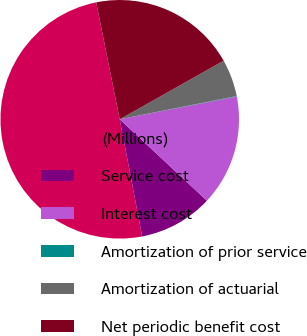Convert chart to OTSL. <chart><loc_0><loc_0><loc_500><loc_500><pie_chart><fcel>(Millions)<fcel>Service cost<fcel>Interest cost<fcel>Amortization of prior service<fcel>Amortization of actuarial<fcel>Net periodic benefit cost<nl><fcel>49.85%<fcel>10.03%<fcel>15.01%<fcel>0.07%<fcel>5.05%<fcel>19.99%<nl></chart> 